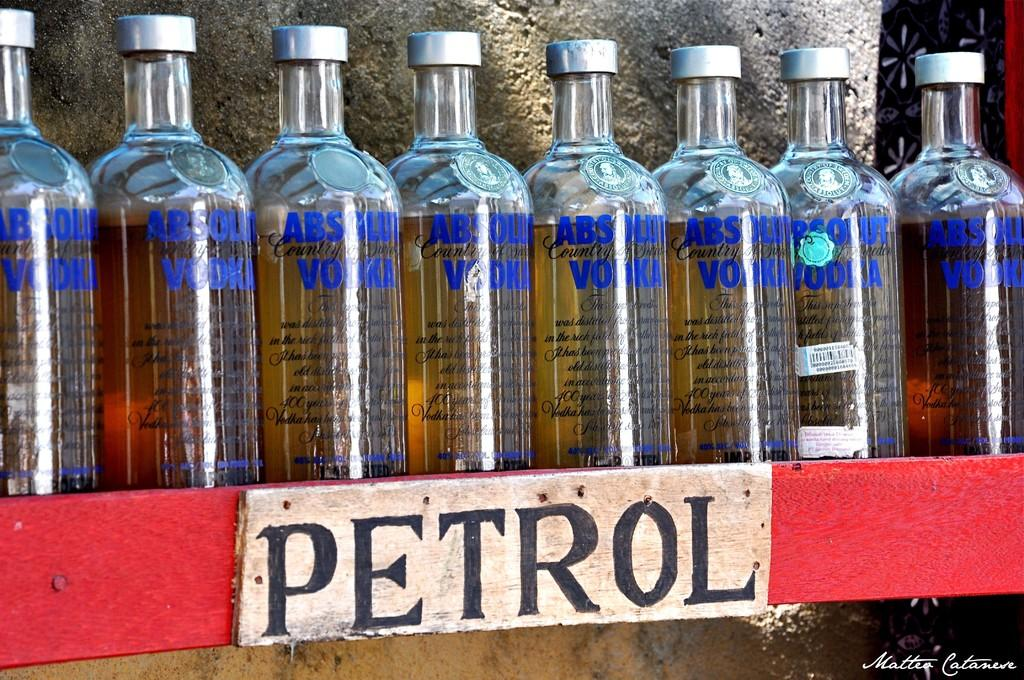Provide a one-sentence caption for the provided image. Absolut Vodka bottles lined up next to each other on a red shelf  with the word Petrol underneath. 